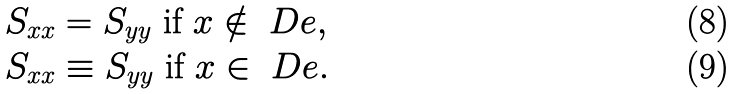<formula> <loc_0><loc_0><loc_500><loc_500>S _ { x x } & = S _ { y y } \text { if } x \notin \ D e , \\ S _ { x x } & \equiv S _ { y y } \text { if } x \in \ D e .</formula> 